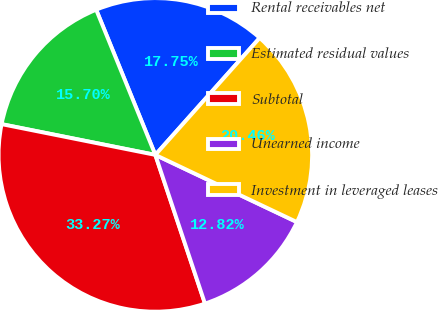Convert chart. <chart><loc_0><loc_0><loc_500><loc_500><pie_chart><fcel>Rental receivables net<fcel>Estimated residual values<fcel>Subtotal<fcel>Unearned income<fcel>Investment in leveraged leases<nl><fcel>17.75%<fcel>15.7%<fcel>33.27%<fcel>12.82%<fcel>20.46%<nl></chart> 